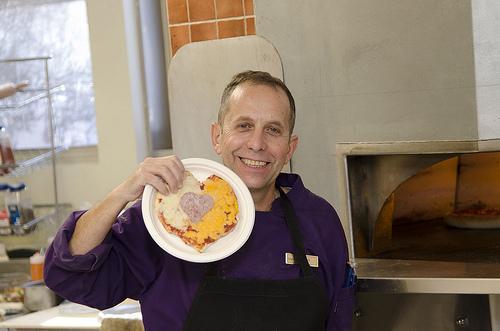How many plates are shown?
Give a very brief answer. 1. 